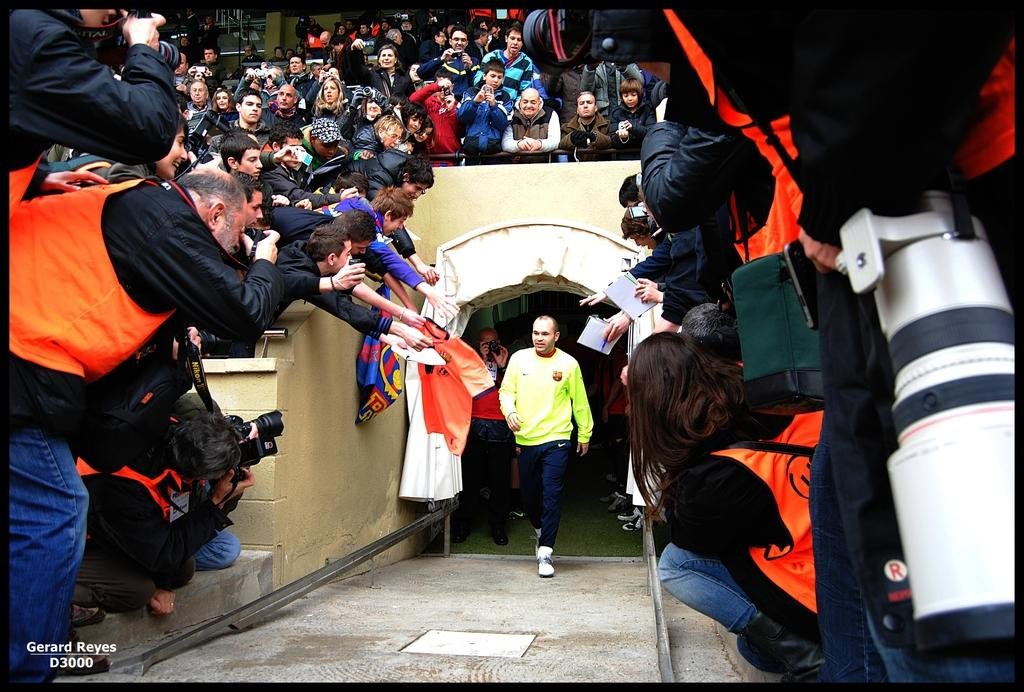What is the person in the image doing? The person in the image is walking. What color is the shirt the person is wearing? The person is wearing a green shirt. What color are the pants the person is wearing? The person is wearing blue pants. Can you describe the group of people in the background? Some people in the group are standing, and some are sitting. What objects are visible in the image that are related to capturing images? There are cameras visible in the image. What type of landmark can be seen in the image? There is no landmark present in the image. What color is the hydrant near the group of people? There is no hydrant present in the image. 